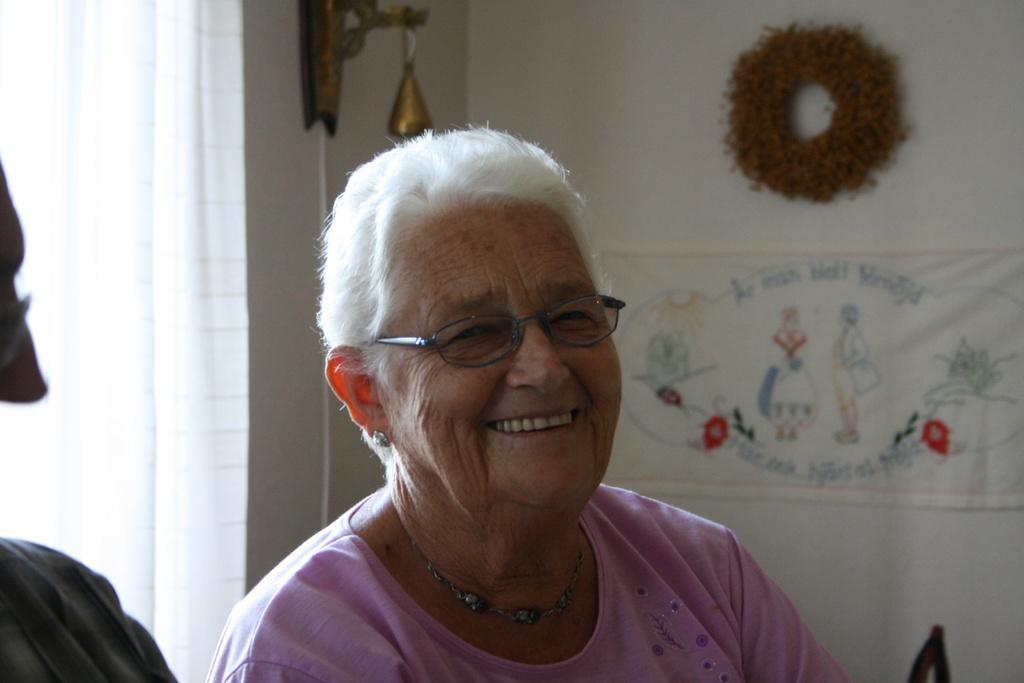How would you summarize this image in a sentence or two? In the foreground of the image there is an old lady. In the background of the image there is a white color curtain. There is a poster on the wall and there are other objects. To the left side of the image there is another person. 